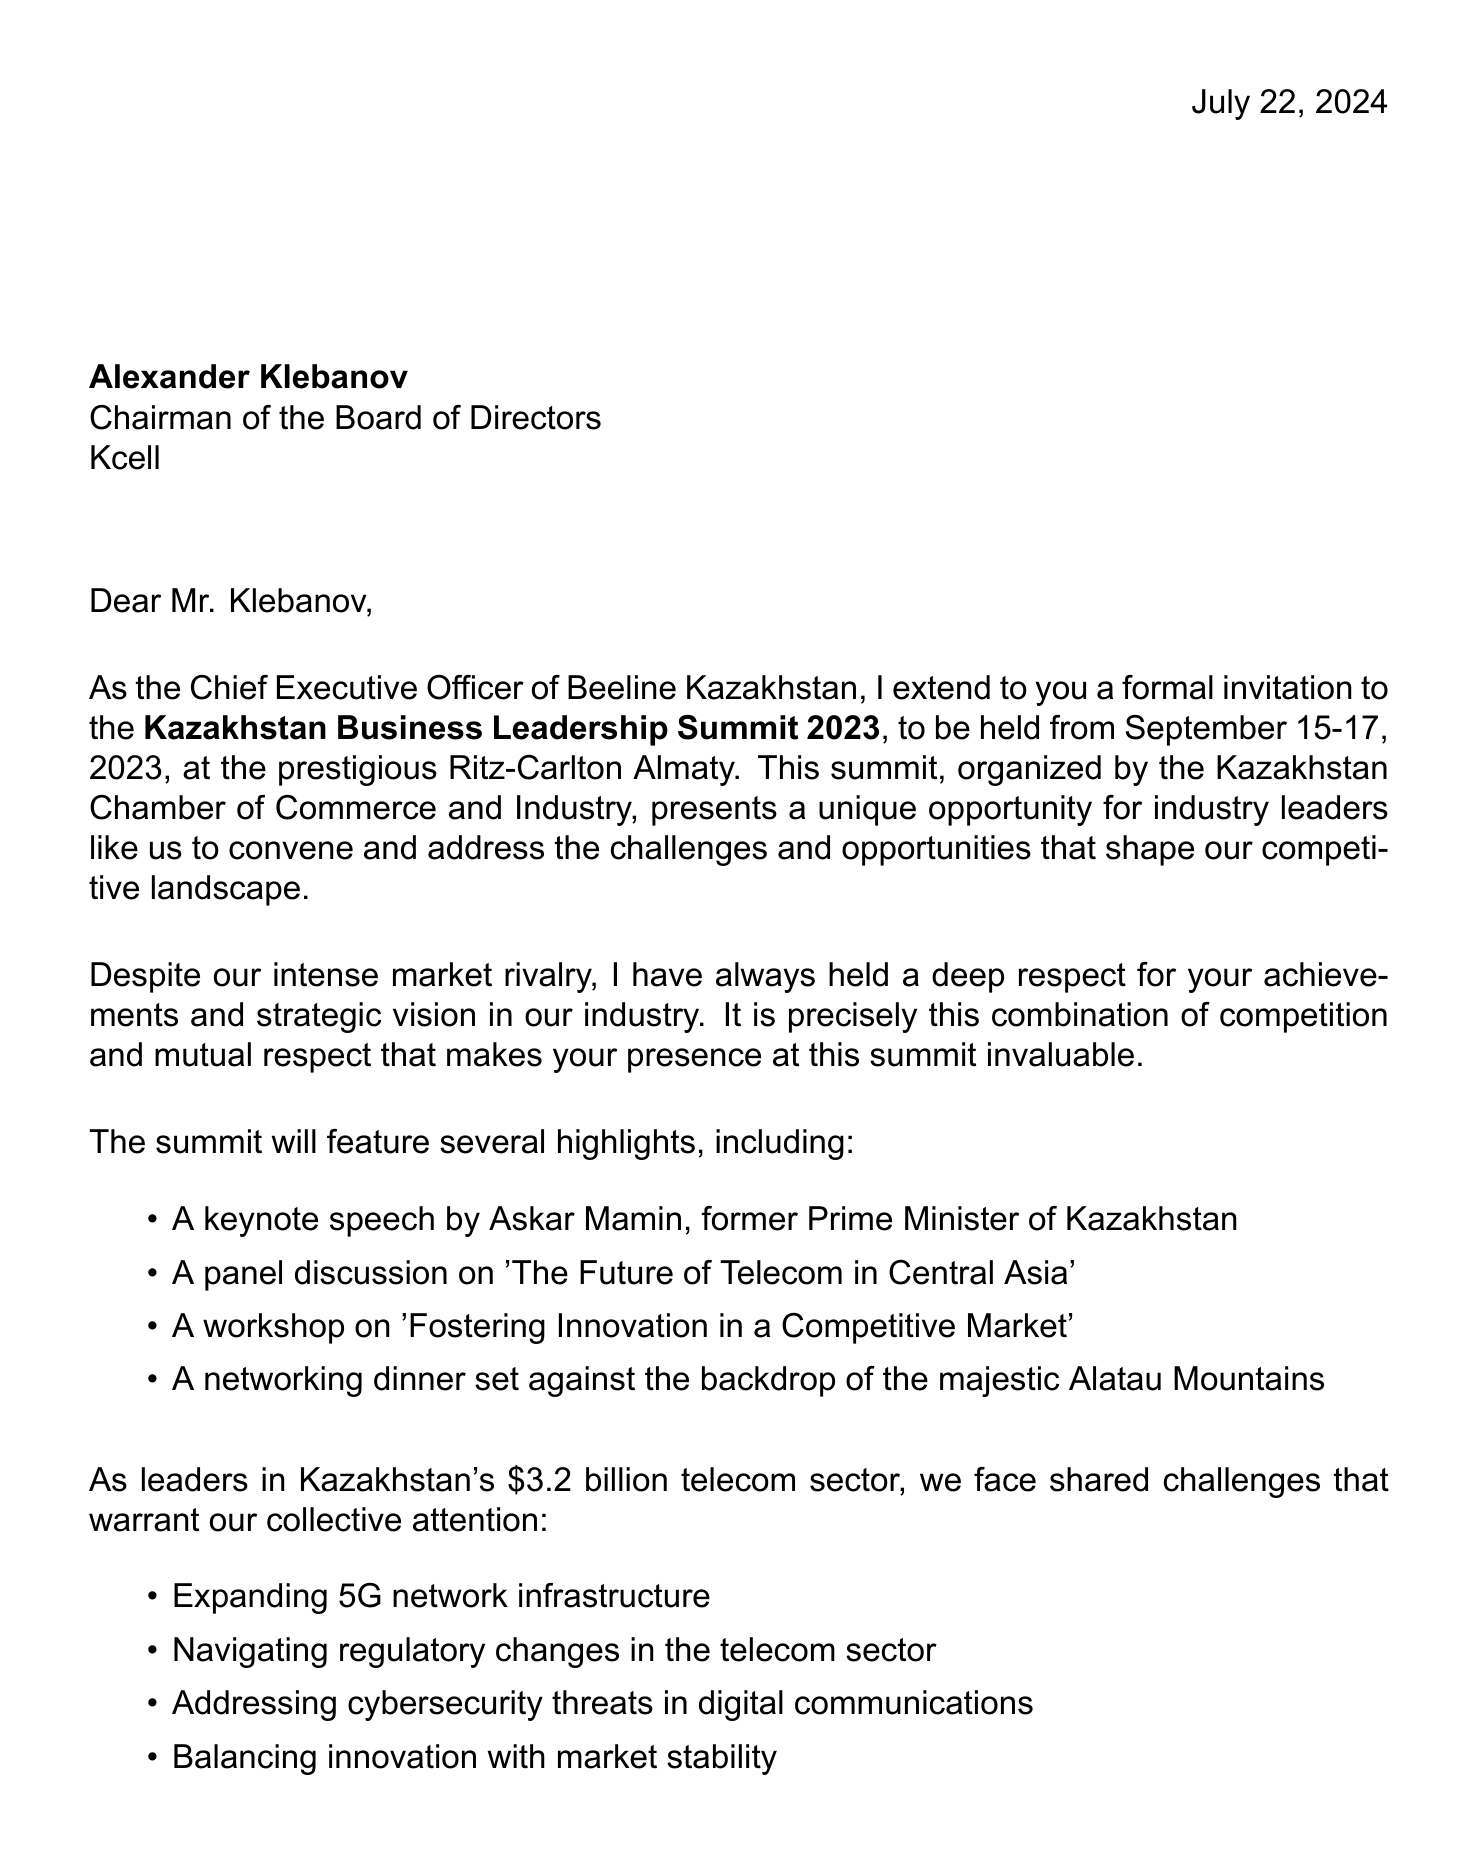What is the name of the event? The name of the event is explicitly mentioned in the invitation details section.
Answer: Kazakhstan Business Leadership Summit 2023 Who is the addressee of the letter? The addressee is identified at the beginning of the letter and includes their name and title.
Answer: Alexander Klebanov What are the dates of the summit? The letter specifies the event dates in the invitation details section.
Answer: September 15-17, 2023 What is one of the shared challenges mentioned? The shared challenges are listed in bullet points in the body of the letter.
Answer: Expanding 5G network infrastructure Who is the sender of the invitation? The sender is introduced at the end of the letter, including their name and position.
Answer: Nurlan Smagulev What is a highlight of the summit? The summit highlights are enumerated in the letter, showcasing notable events.
Answer: Keynote speech by Askar Mamin What industry does the letter refer to? The document mentions the specific industry multiple times.
Answer: Telecom sector What position does Alexander Klebanov hold? The letter specifies the position of the addressee directly after their name.
Answer: Chairman of the Board of Directors What is a purpose of the invitation? The letter outlines several purposes for the invitation, focusing on collaboration and exchange.
Answer: Explore potential collaborations on shared challenges What is included in the closing remarks of the letter? The closing remarks combine a personal note and a future outlook that summarizes the relationship.
Answer: Despite our market rivalry, I have always admired your strategic vision and leadership in our industry 